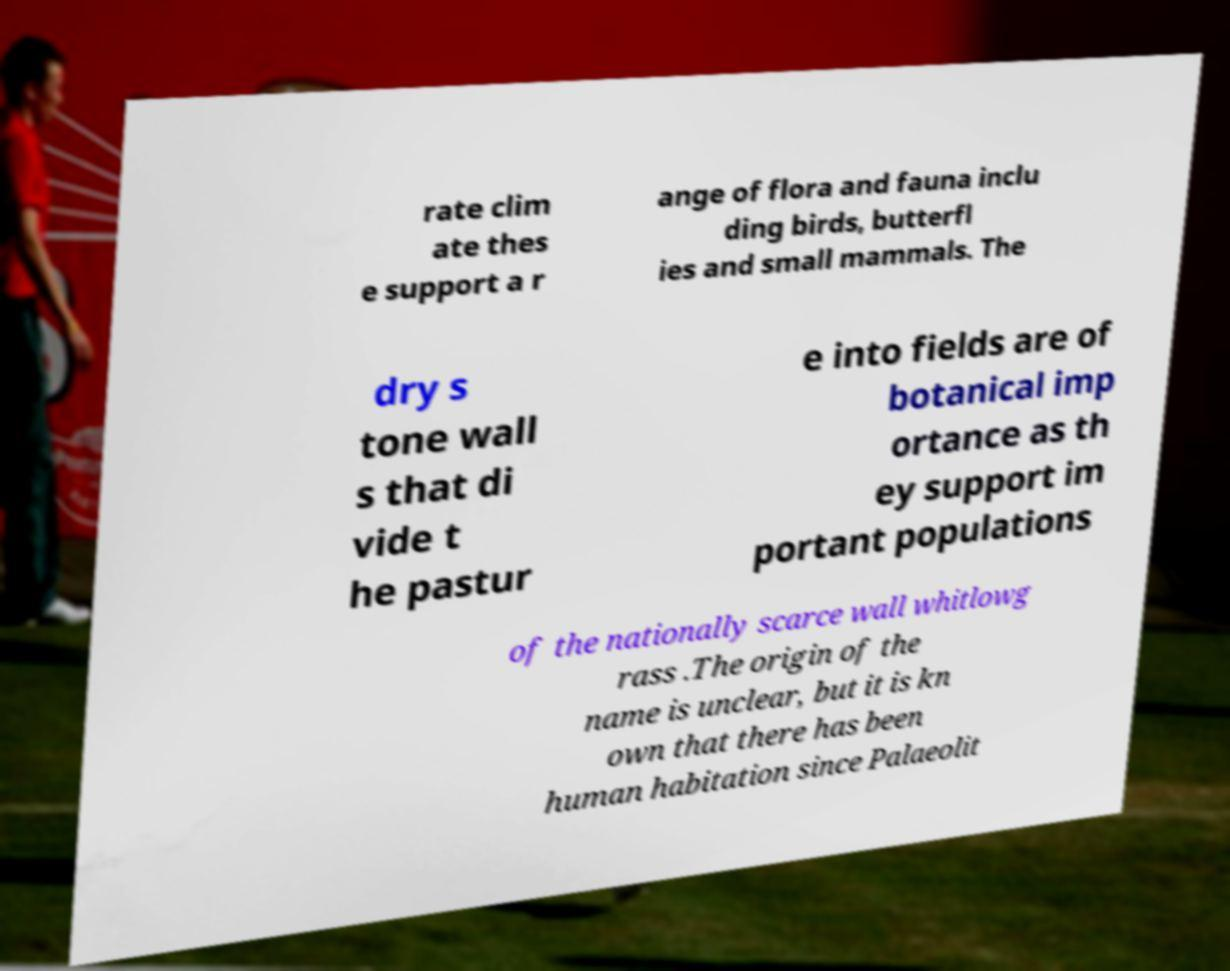There's text embedded in this image that I need extracted. Can you transcribe it verbatim? rate clim ate thes e support a r ange of flora and fauna inclu ding birds, butterfl ies and small mammals. The dry s tone wall s that di vide t he pastur e into fields are of botanical imp ortance as th ey support im portant populations of the nationally scarce wall whitlowg rass .The origin of the name is unclear, but it is kn own that there has been human habitation since Palaeolit 